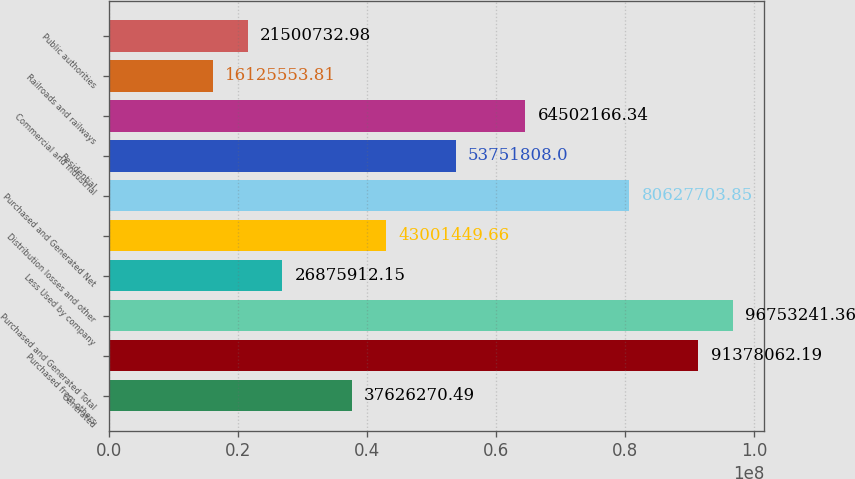Convert chart. <chart><loc_0><loc_0><loc_500><loc_500><bar_chart><fcel>Generated<fcel>Purchased from others<fcel>Purchased and Generated Total<fcel>Less Used by company<fcel>Distribution losses and other<fcel>Purchased and Generated Net<fcel>Residential<fcel>Commercial and industrial<fcel>Railroads and railways<fcel>Public authorities<nl><fcel>3.76263e+07<fcel>9.13781e+07<fcel>9.67532e+07<fcel>2.68759e+07<fcel>4.30014e+07<fcel>8.06277e+07<fcel>5.37518e+07<fcel>6.45022e+07<fcel>1.61256e+07<fcel>2.15007e+07<nl></chart> 